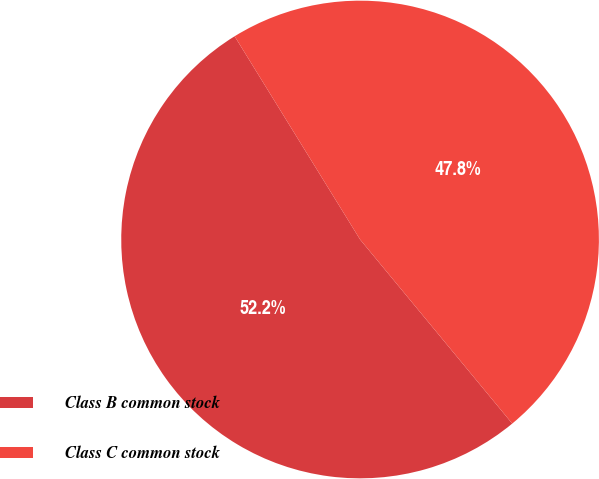Convert chart to OTSL. <chart><loc_0><loc_0><loc_500><loc_500><pie_chart><fcel>Class B common stock<fcel>Class C common stock<nl><fcel>52.19%<fcel>47.81%<nl></chart> 